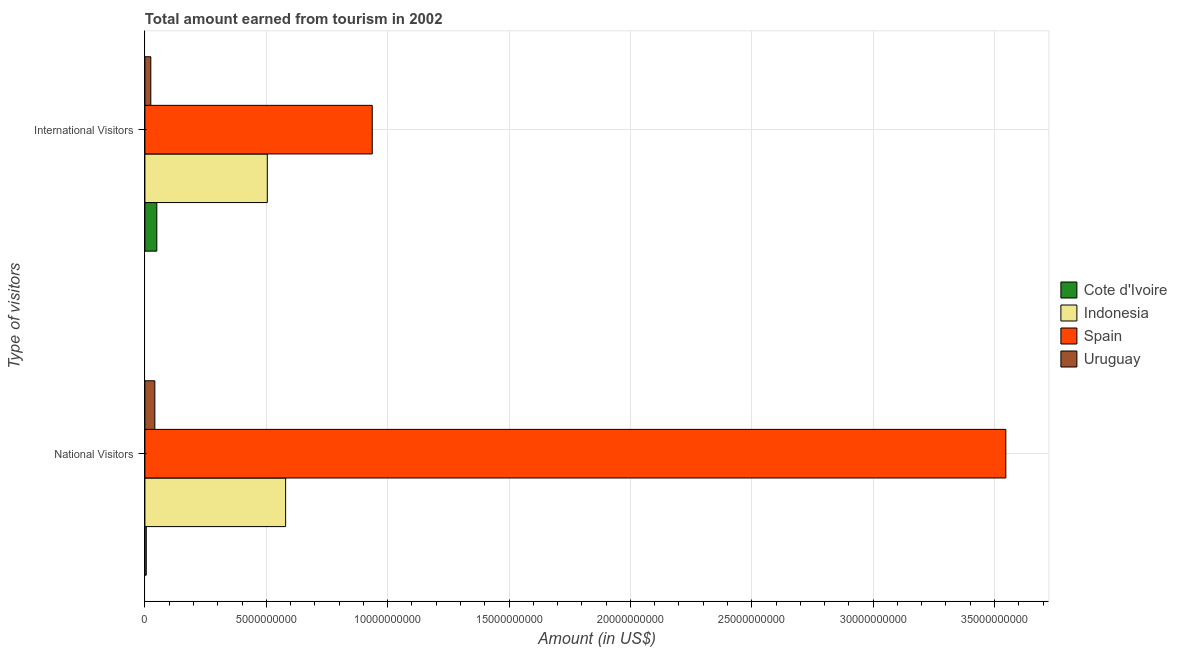How many groups of bars are there?
Your answer should be very brief. 2. Are the number of bars per tick equal to the number of legend labels?
Your answer should be very brief. Yes. Are the number of bars on each tick of the Y-axis equal?
Make the answer very short. Yes. How many bars are there on the 2nd tick from the top?
Provide a short and direct response. 4. What is the label of the 2nd group of bars from the top?
Keep it short and to the point. National Visitors. What is the amount earned from national visitors in Indonesia?
Make the answer very short. 5.80e+09. Across all countries, what is the maximum amount earned from international visitors?
Offer a very short reply. 9.37e+09. Across all countries, what is the minimum amount earned from international visitors?
Your answer should be compact. 2.43e+08. In which country was the amount earned from national visitors minimum?
Offer a terse response. Cote d'Ivoire. What is the total amount earned from international visitors in the graph?
Your response must be concise. 1.51e+1. What is the difference between the amount earned from international visitors in Spain and that in Cote d'Ivoire?
Ensure brevity in your answer.  8.88e+09. What is the difference between the amount earned from national visitors in Spain and the amount earned from international visitors in Cote d'Ivoire?
Provide a succinct answer. 3.50e+1. What is the average amount earned from international visitors per country?
Your response must be concise. 3.79e+09. What is the difference between the amount earned from international visitors and amount earned from national visitors in Indonesia?
Provide a succinct answer. -7.55e+08. What is the ratio of the amount earned from national visitors in Indonesia to that in Spain?
Provide a short and direct response. 0.16. In how many countries, is the amount earned from international visitors greater than the average amount earned from international visitors taken over all countries?
Make the answer very short. 2. What does the 3rd bar from the bottom in International Visitors represents?
Give a very brief answer. Spain. How many bars are there?
Offer a terse response. 8. Are all the bars in the graph horizontal?
Your response must be concise. Yes. How many countries are there in the graph?
Your answer should be very brief. 4. Does the graph contain any zero values?
Your answer should be compact. No. How are the legend labels stacked?
Give a very brief answer. Vertical. What is the title of the graph?
Your response must be concise. Total amount earned from tourism in 2002. Does "Japan" appear as one of the legend labels in the graph?
Provide a short and direct response. No. What is the label or title of the X-axis?
Ensure brevity in your answer.  Amount (in US$). What is the label or title of the Y-axis?
Offer a terse response. Type of visitors. What is the Amount (in US$) of Cote d'Ivoire in National Visitors?
Keep it short and to the point. 5.60e+07. What is the Amount (in US$) in Indonesia in National Visitors?
Keep it short and to the point. 5.80e+09. What is the Amount (in US$) of Spain in National Visitors?
Provide a short and direct response. 3.55e+1. What is the Amount (in US$) of Uruguay in National Visitors?
Keep it short and to the point. 4.09e+08. What is the Amount (in US$) in Cote d'Ivoire in International Visitors?
Your answer should be very brief. 4.90e+08. What is the Amount (in US$) in Indonesia in International Visitors?
Your response must be concise. 5.04e+09. What is the Amount (in US$) in Spain in International Visitors?
Your answer should be very brief. 9.37e+09. What is the Amount (in US$) in Uruguay in International Visitors?
Your answer should be very brief. 2.43e+08. Across all Type of visitors, what is the maximum Amount (in US$) in Cote d'Ivoire?
Keep it short and to the point. 4.90e+08. Across all Type of visitors, what is the maximum Amount (in US$) in Indonesia?
Make the answer very short. 5.80e+09. Across all Type of visitors, what is the maximum Amount (in US$) of Spain?
Your response must be concise. 3.55e+1. Across all Type of visitors, what is the maximum Amount (in US$) of Uruguay?
Your answer should be compact. 4.09e+08. Across all Type of visitors, what is the minimum Amount (in US$) of Cote d'Ivoire?
Your answer should be compact. 5.60e+07. Across all Type of visitors, what is the minimum Amount (in US$) of Indonesia?
Provide a succinct answer. 5.04e+09. Across all Type of visitors, what is the minimum Amount (in US$) in Spain?
Offer a terse response. 9.37e+09. Across all Type of visitors, what is the minimum Amount (in US$) in Uruguay?
Give a very brief answer. 2.43e+08. What is the total Amount (in US$) of Cote d'Ivoire in the graph?
Your answer should be compact. 5.46e+08. What is the total Amount (in US$) of Indonesia in the graph?
Give a very brief answer. 1.08e+1. What is the total Amount (in US$) in Spain in the graph?
Ensure brevity in your answer.  4.48e+1. What is the total Amount (in US$) of Uruguay in the graph?
Offer a terse response. 6.52e+08. What is the difference between the Amount (in US$) of Cote d'Ivoire in National Visitors and that in International Visitors?
Provide a short and direct response. -4.34e+08. What is the difference between the Amount (in US$) in Indonesia in National Visitors and that in International Visitors?
Offer a terse response. 7.55e+08. What is the difference between the Amount (in US$) of Spain in National Visitors and that in International Visitors?
Provide a short and direct response. 2.61e+1. What is the difference between the Amount (in US$) in Uruguay in National Visitors and that in International Visitors?
Ensure brevity in your answer.  1.66e+08. What is the difference between the Amount (in US$) of Cote d'Ivoire in National Visitors and the Amount (in US$) of Indonesia in International Visitors?
Provide a short and direct response. -4.99e+09. What is the difference between the Amount (in US$) of Cote d'Ivoire in National Visitors and the Amount (in US$) of Spain in International Visitors?
Provide a succinct answer. -9.31e+09. What is the difference between the Amount (in US$) of Cote d'Ivoire in National Visitors and the Amount (in US$) of Uruguay in International Visitors?
Your answer should be compact. -1.87e+08. What is the difference between the Amount (in US$) of Indonesia in National Visitors and the Amount (in US$) of Spain in International Visitors?
Provide a short and direct response. -3.57e+09. What is the difference between the Amount (in US$) of Indonesia in National Visitors and the Amount (in US$) of Uruguay in International Visitors?
Ensure brevity in your answer.  5.55e+09. What is the difference between the Amount (in US$) in Spain in National Visitors and the Amount (in US$) in Uruguay in International Visitors?
Provide a succinct answer. 3.52e+1. What is the average Amount (in US$) in Cote d'Ivoire per Type of visitors?
Offer a terse response. 2.73e+08. What is the average Amount (in US$) of Indonesia per Type of visitors?
Ensure brevity in your answer.  5.42e+09. What is the average Amount (in US$) in Spain per Type of visitors?
Make the answer very short. 2.24e+1. What is the average Amount (in US$) in Uruguay per Type of visitors?
Your answer should be very brief. 3.26e+08. What is the difference between the Amount (in US$) of Cote d'Ivoire and Amount (in US$) of Indonesia in National Visitors?
Make the answer very short. -5.74e+09. What is the difference between the Amount (in US$) in Cote d'Ivoire and Amount (in US$) in Spain in National Visitors?
Offer a terse response. -3.54e+1. What is the difference between the Amount (in US$) of Cote d'Ivoire and Amount (in US$) of Uruguay in National Visitors?
Offer a terse response. -3.53e+08. What is the difference between the Amount (in US$) in Indonesia and Amount (in US$) in Spain in National Visitors?
Offer a terse response. -2.97e+1. What is the difference between the Amount (in US$) in Indonesia and Amount (in US$) in Uruguay in National Visitors?
Offer a very short reply. 5.39e+09. What is the difference between the Amount (in US$) of Spain and Amount (in US$) of Uruguay in National Visitors?
Provide a short and direct response. 3.51e+1. What is the difference between the Amount (in US$) in Cote d'Ivoire and Amount (in US$) in Indonesia in International Visitors?
Offer a very short reply. -4.55e+09. What is the difference between the Amount (in US$) of Cote d'Ivoire and Amount (in US$) of Spain in International Visitors?
Your answer should be very brief. -8.88e+09. What is the difference between the Amount (in US$) in Cote d'Ivoire and Amount (in US$) in Uruguay in International Visitors?
Give a very brief answer. 2.47e+08. What is the difference between the Amount (in US$) in Indonesia and Amount (in US$) in Spain in International Visitors?
Ensure brevity in your answer.  -4.32e+09. What is the difference between the Amount (in US$) in Indonesia and Amount (in US$) in Uruguay in International Visitors?
Make the answer very short. 4.80e+09. What is the difference between the Amount (in US$) in Spain and Amount (in US$) in Uruguay in International Visitors?
Keep it short and to the point. 9.12e+09. What is the ratio of the Amount (in US$) of Cote d'Ivoire in National Visitors to that in International Visitors?
Offer a terse response. 0.11. What is the ratio of the Amount (in US$) of Indonesia in National Visitors to that in International Visitors?
Your response must be concise. 1.15. What is the ratio of the Amount (in US$) in Spain in National Visitors to that in International Visitors?
Offer a very short reply. 3.79. What is the ratio of the Amount (in US$) of Uruguay in National Visitors to that in International Visitors?
Your response must be concise. 1.68. What is the difference between the highest and the second highest Amount (in US$) of Cote d'Ivoire?
Your answer should be compact. 4.34e+08. What is the difference between the highest and the second highest Amount (in US$) in Indonesia?
Offer a very short reply. 7.55e+08. What is the difference between the highest and the second highest Amount (in US$) of Spain?
Offer a very short reply. 2.61e+1. What is the difference between the highest and the second highest Amount (in US$) of Uruguay?
Provide a succinct answer. 1.66e+08. What is the difference between the highest and the lowest Amount (in US$) in Cote d'Ivoire?
Provide a succinct answer. 4.34e+08. What is the difference between the highest and the lowest Amount (in US$) of Indonesia?
Keep it short and to the point. 7.55e+08. What is the difference between the highest and the lowest Amount (in US$) in Spain?
Keep it short and to the point. 2.61e+1. What is the difference between the highest and the lowest Amount (in US$) of Uruguay?
Give a very brief answer. 1.66e+08. 